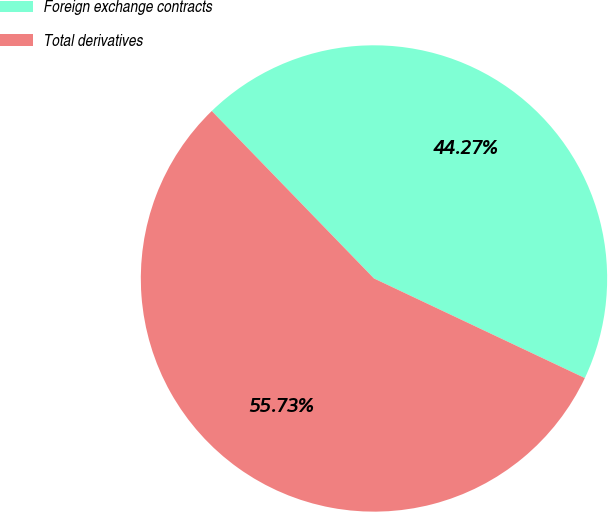Convert chart to OTSL. <chart><loc_0><loc_0><loc_500><loc_500><pie_chart><fcel>Foreign exchange contracts<fcel>Total derivatives<nl><fcel>44.27%<fcel>55.73%<nl></chart> 